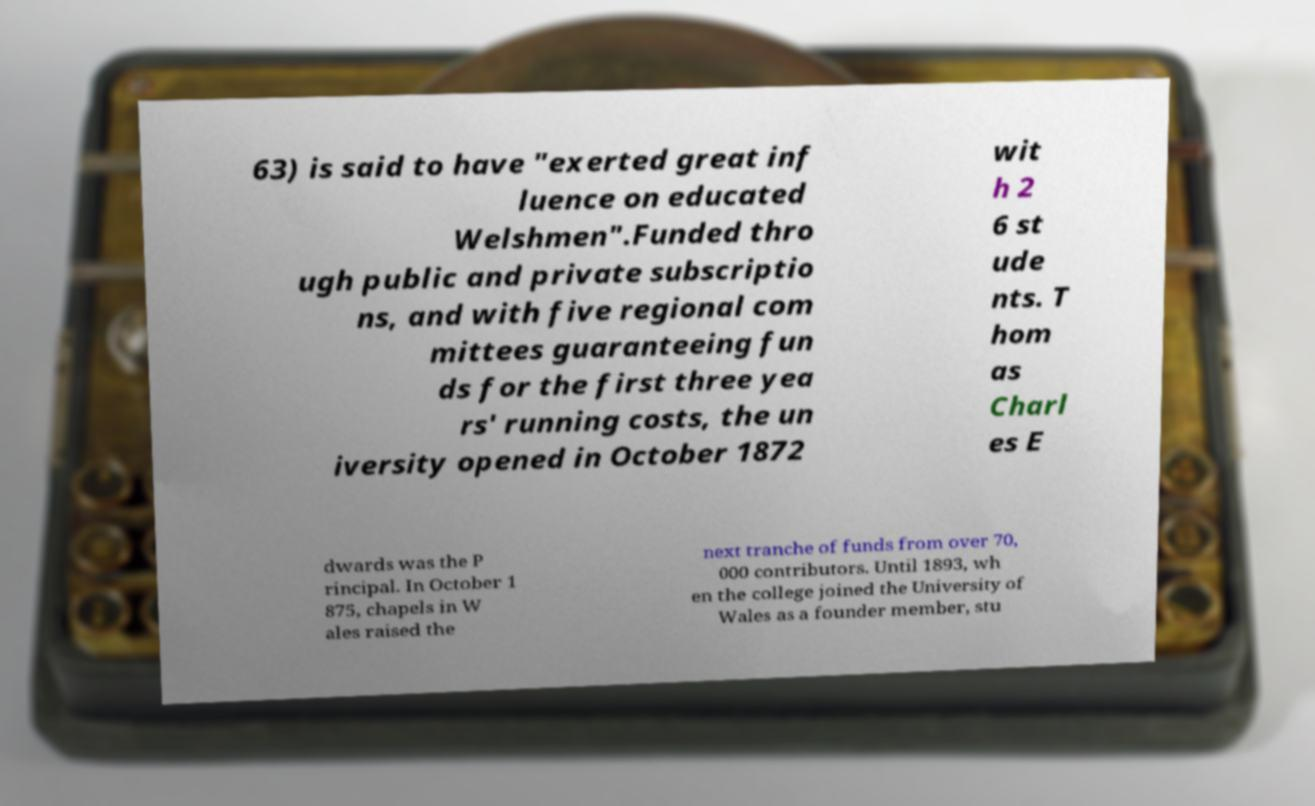Could you assist in decoding the text presented in this image and type it out clearly? 63) is said to have "exerted great inf luence on educated Welshmen".Funded thro ugh public and private subscriptio ns, and with five regional com mittees guaranteeing fun ds for the first three yea rs' running costs, the un iversity opened in October 1872 wit h 2 6 st ude nts. T hom as Charl es E dwards was the P rincipal. In October 1 875, chapels in W ales raised the next tranche of funds from over 70, 000 contributors. Until 1893, wh en the college joined the University of Wales as a founder member, stu 